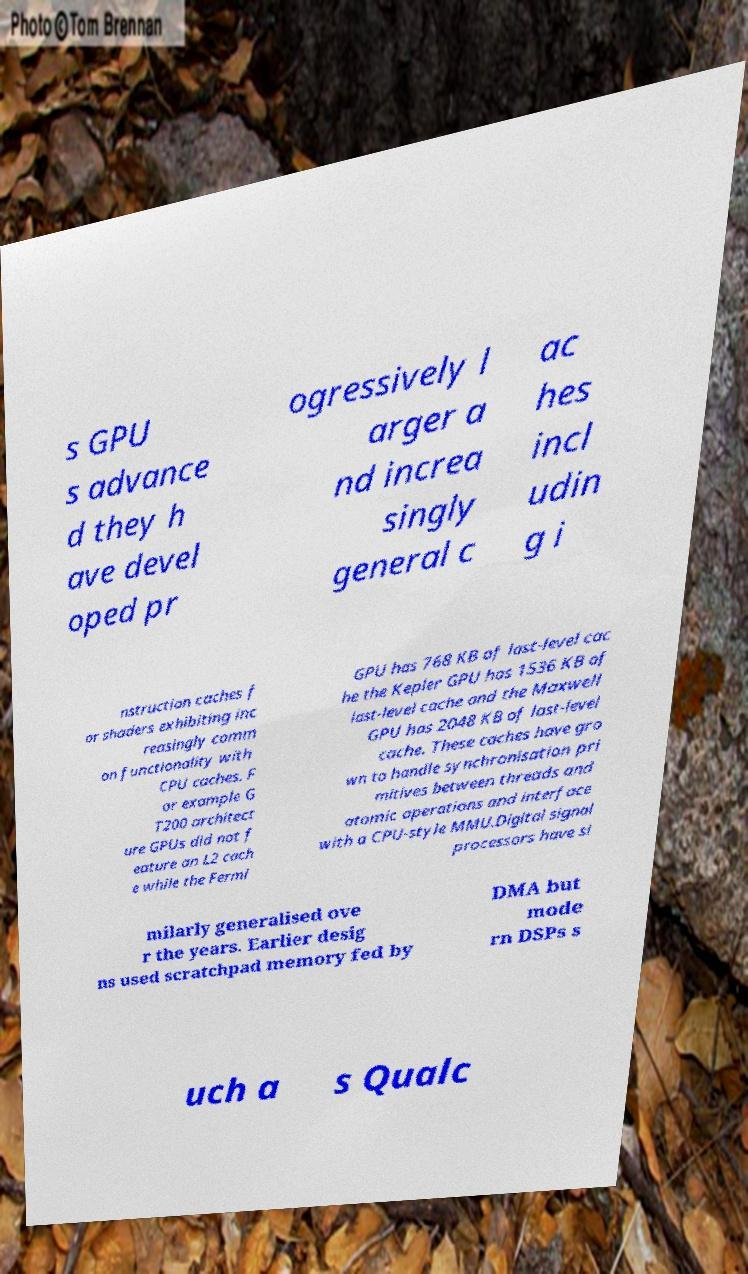Please identify and transcribe the text found in this image. s GPU s advance d they h ave devel oped pr ogressively l arger a nd increa singly general c ac hes incl udin g i nstruction caches f or shaders exhibiting inc reasingly comm on functionality with CPU caches. F or example G T200 architect ure GPUs did not f eature an L2 cach e while the Fermi GPU has 768 KB of last-level cac he the Kepler GPU has 1536 KB of last-level cache and the Maxwell GPU has 2048 KB of last-level cache. These caches have gro wn to handle synchronisation pri mitives between threads and atomic operations and interface with a CPU-style MMU.Digital signal processors have si milarly generalised ove r the years. Earlier desig ns used scratchpad memory fed by DMA but mode rn DSPs s uch a s Qualc 